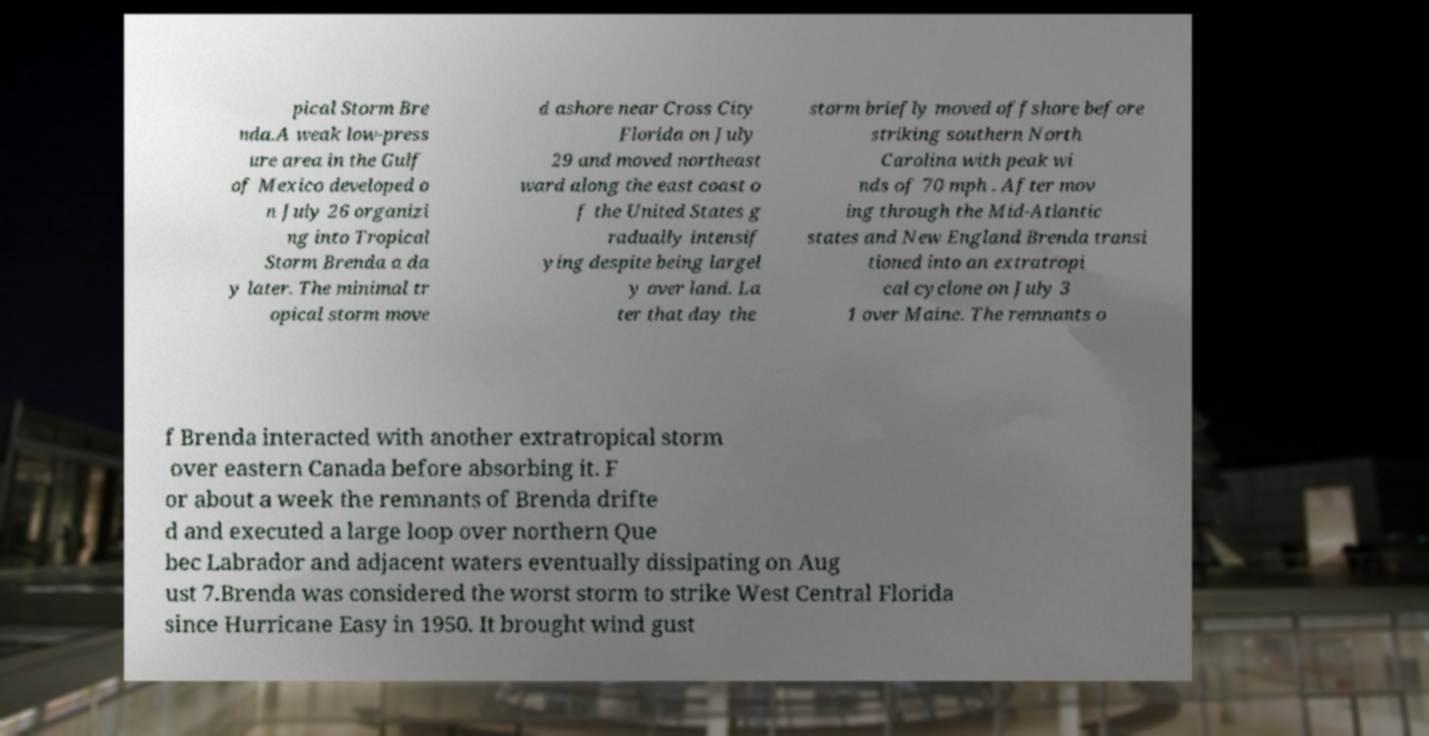Please identify and transcribe the text found in this image. pical Storm Bre nda.A weak low-press ure area in the Gulf of Mexico developed o n July 26 organizi ng into Tropical Storm Brenda a da y later. The minimal tr opical storm move d ashore near Cross City Florida on July 29 and moved northeast ward along the east coast o f the United States g radually intensif ying despite being largel y over land. La ter that day the storm briefly moved offshore before striking southern North Carolina with peak wi nds of 70 mph . After mov ing through the Mid-Atlantic states and New England Brenda transi tioned into an extratropi cal cyclone on July 3 1 over Maine. The remnants o f Brenda interacted with another extratropical storm over eastern Canada before absorbing it. F or about a week the remnants of Brenda drifte d and executed a large loop over northern Que bec Labrador and adjacent waters eventually dissipating on Aug ust 7.Brenda was considered the worst storm to strike West Central Florida since Hurricane Easy in 1950. It brought wind gust 